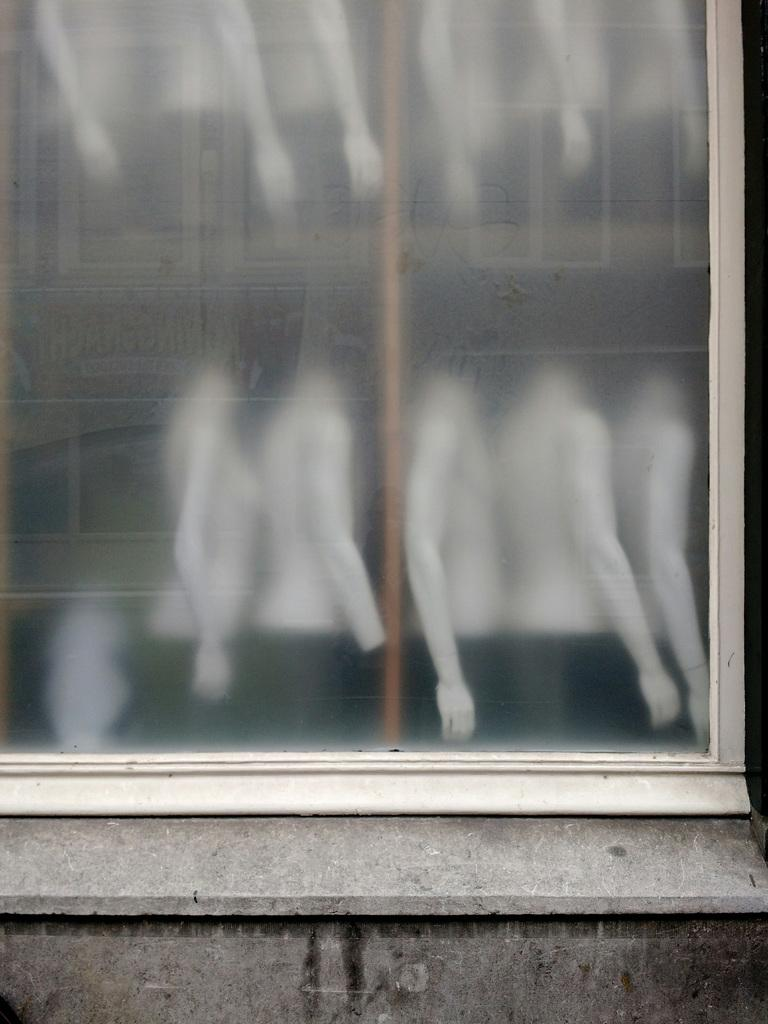What object is present in the image that is typically used for drinking? There is a glass in the image. What type of figures can be seen in the image? There are mannequins in the image. What is in the pocket of the mannequin in the image? There are no pockets on the mannequins in the image, as they are not actual clothing items. How many forks can be seen in the image? There are no forks present in the image. 